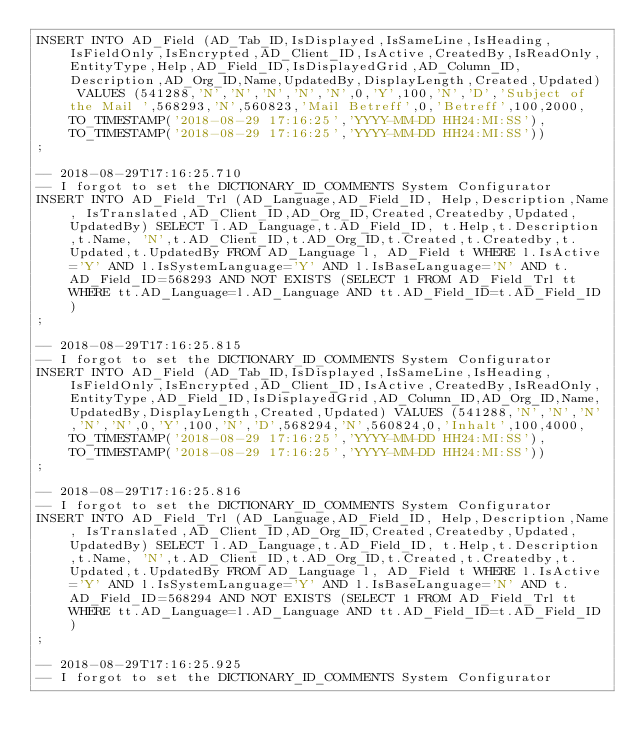<code> <loc_0><loc_0><loc_500><loc_500><_SQL_>INSERT INTO AD_Field (AD_Tab_ID,IsDisplayed,IsSameLine,IsHeading,IsFieldOnly,IsEncrypted,AD_Client_ID,IsActive,CreatedBy,IsReadOnly,EntityType,Help,AD_Field_ID,IsDisplayedGrid,AD_Column_ID,Description,AD_Org_ID,Name,UpdatedBy,DisplayLength,Created,Updated) VALUES (541288,'N','N','N','N','N',0,'Y',100,'N','D','Subject of the Mail ',568293,'N',560823,'Mail Betreff',0,'Betreff',100,2000,TO_TIMESTAMP('2018-08-29 17:16:25','YYYY-MM-DD HH24:MI:SS'),TO_TIMESTAMP('2018-08-29 17:16:25','YYYY-MM-DD HH24:MI:SS'))
;

-- 2018-08-29T17:16:25.710
-- I forgot to set the DICTIONARY_ID_COMMENTS System Configurator
INSERT INTO AD_Field_Trl (AD_Language,AD_Field_ID, Help,Description,Name, IsTranslated,AD_Client_ID,AD_Org_ID,Created,Createdby,Updated,UpdatedBy) SELECT l.AD_Language,t.AD_Field_ID, t.Help,t.Description,t.Name, 'N',t.AD_Client_ID,t.AD_Org_ID,t.Created,t.Createdby,t.Updated,t.UpdatedBy FROM AD_Language l, AD_Field t WHERE l.IsActive='Y' AND l.IsSystemLanguage='Y' AND l.IsBaseLanguage='N' AND t.AD_Field_ID=568293 AND NOT EXISTS (SELECT 1 FROM AD_Field_Trl tt WHERE tt.AD_Language=l.AD_Language AND tt.AD_Field_ID=t.AD_Field_ID)
;

-- 2018-08-29T17:16:25.815
-- I forgot to set the DICTIONARY_ID_COMMENTS System Configurator
INSERT INTO AD_Field (AD_Tab_ID,IsDisplayed,IsSameLine,IsHeading,IsFieldOnly,IsEncrypted,AD_Client_ID,IsActive,CreatedBy,IsReadOnly,EntityType,AD_Field_ID,IsDisplayedGrid,AD_Column_ID,AD_Org_ID,Name,UpdatedBy,DisplayLength,Created,Updated) VALUES (541288,'N','N','N','N','N',0,'Y',100,'N','D',568294,'N',560824,0,'Inhalt',100,4000,TO_TIMESTAMP('2018-08-29 17:16:25','YYYY-MM-DD HH24:MI:SS'),TO_TIMESTAMP('2018-08-29 17:16:25','YYYY-MM-DD HH24:MI:SS'))
;

-- 2018-08-29T17:16:25.816
-- I forgot to set the DICTIONARY_ID_COMMENTS System Configurator
INSERT INTO AD_Field_Trl (AD_Language,AD_Field_ID, Help,Description,Name, IsTranslated,AD_Client_ID,AD_Org_ID,Created,Createdby,Updated,UpdatedBy) SELECT l.AD_Language,t.AD_Field_ID, t.Help,t.Description,t.Name, 'N',t.AD_Client_ID,t.AD_Org_ID,t.Created,t.Createdby,t.Updated,t.UpdatedBy FROM AD_Language l, AD_Field t WHERE l.IsActive='Y' AND l.IsSystemLanguage='Y' AND l.IsBaseLanguage='N' AND t.AD_Field_ID=568294 AND NOT EXISTS (SELECT 1 FROM AD_Field_Trl tt WHERE tt.AD_Language=l.AD_Language AND tt.AD_Field_ID=t.AD_Field_ID)
;

-- 2018-08-29T17:16:25.925
-- I forgot to set the DICTIONARY_ID_COMMENTS System Configurator</code> 